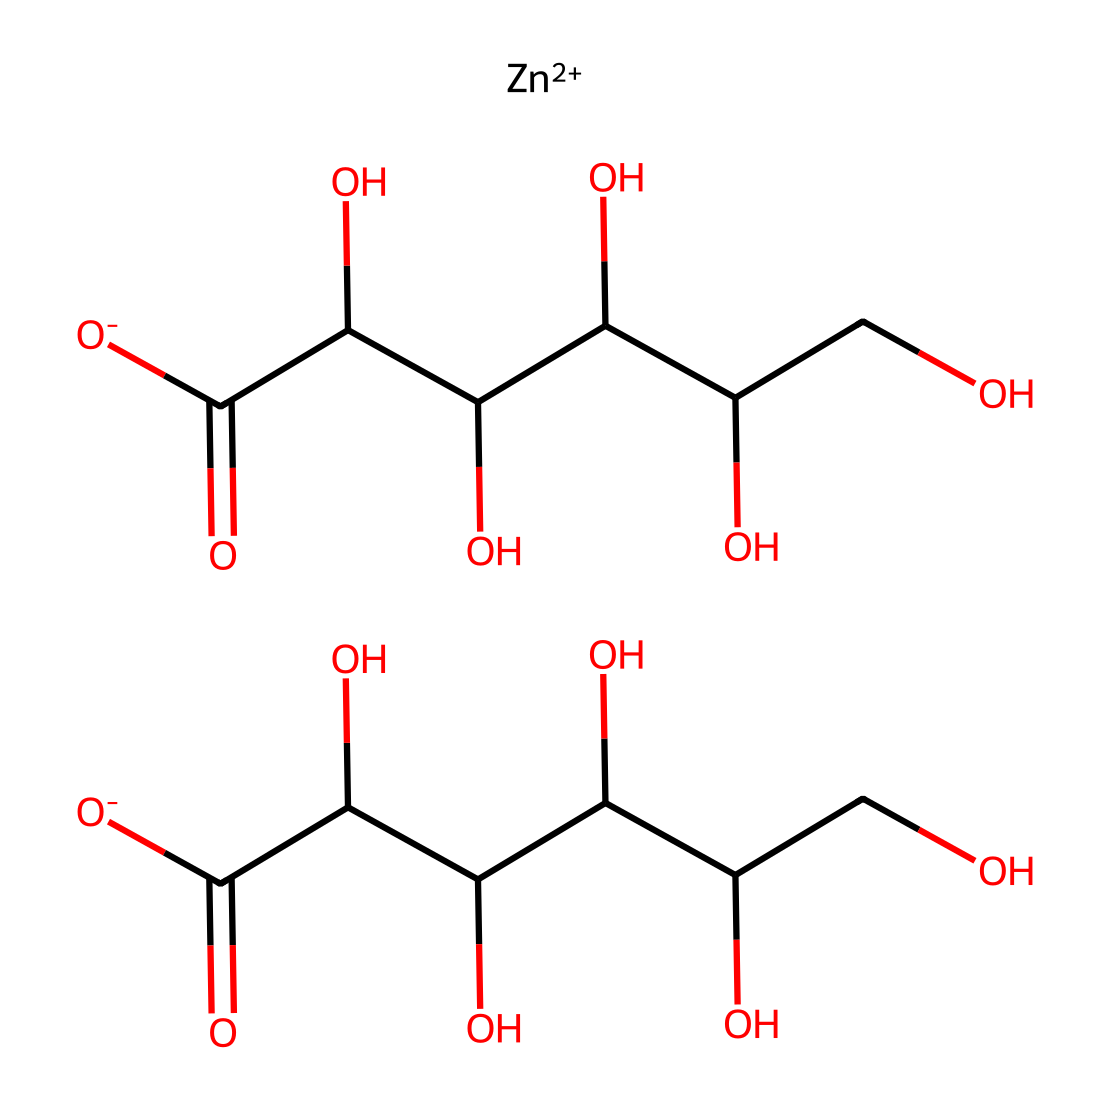What is the name of the compound represented by the SMILES? The SMILES notation indicates the presence of zinc ions and gluconate anions, formed from the structure of gluconic acid. Thus, the compound is zinc gluconate.
Answer: zinc gluconate How many hydroxyl (–OH) groups are present in zinc gluconate? By examining the structure, we can count the number of hydroxyl (–OH) groups present in the monosaccharide part of each gluconate ion. There are five hydroxyl groups in total.
Answer: five What is the central metal ion in the compound? The SMILES representation shows [Zn++] as a cation, indicating the presence of zinc as the central metal ion in this complex.
Answer: zinc How many carboxylate (–COO−) groups are in zinc gluconate? The structure shows two carboxylate groups attached to the gluconate backbone. Therefore, there are two –COO− groups present in the compound.
Answer: two What type of compound is zinc gluconate classified as? Zinc gluconate can be categorized as a coordination compound due to the interaction between zinc ions and the gluconate ions lending a specific structure and function to the compound.
Answer: coordination compound How does zinc gluconate function as an electrolyte? As an electrolyte, zinc gluconate dissociates into zinc and gluconate ions in solution, which helps to conduct electricity when dissolved in water, essential for various physiological functions.
Answer: dissociates into ions 